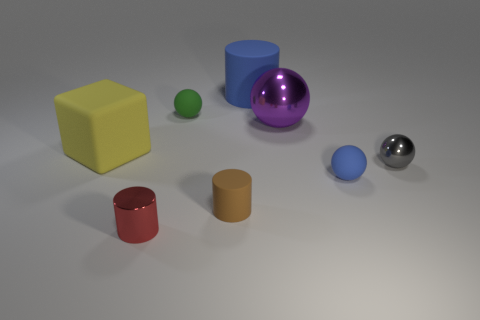What number of objects are both behind the green matte sphere and in front of the big purple ball?
Give a very brief answer. 0. The large rubber cylinder is what color?
Keep it short and to the point. Blue. Are there any big blocks that have the same material as the green thing?
Your answer should be compact. Yes. There is a matte cylinder behind the blue rubber thing that is in front of the green rubber object; is there a small gray metallic thing that is to the right of it?
Give a very brief answer. Yes. There is a gray metal sphere; are there any rubber objects behind it?
Your answer should be very brief. Yes. Are there any things that have the same color as the large cylinder?
Provide a short and direct response. Yes. What number of small objects are metal cylinders or metallic balls?
Offer a very short reply. 2. Do the blue thing that is in front of the green object and the small red cylinder have the same material?
Offer a very short reply. No. There is a metal thing on the left side of the large matte thing that is behind the small sphere that is behind the yellow rubber cube; what shape is it?
Ensure brevity in your answer.  Cylinder. How many purple things are either big metal objects or tiny metal things?
Provide a short and direct response. 1. 